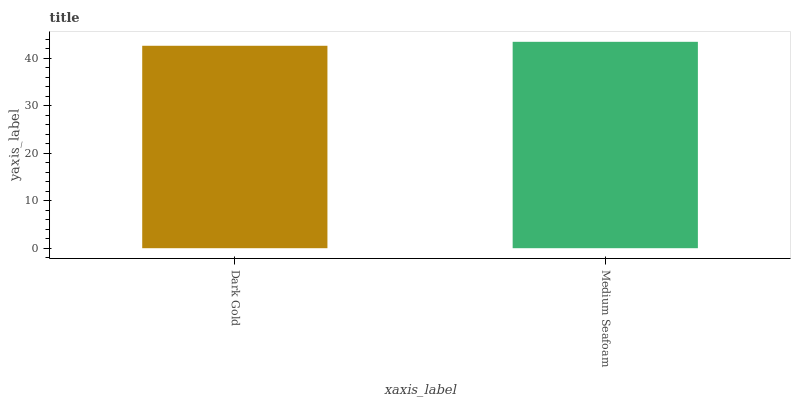Is Dark Gold the minimum?
Answer yes or no. Yes. Is Medium Seafoam the maximum?
Answer yes or no. Yes. Is Medium Seafoam the minimum?
Answer yes or no. No. Is Medium Seafoam greater than Dark Gold?
Answer yes or no. Yes. Is Dark Gold less than Medium Seafoam?
Answer yes or no. Yes. Is Dark Gold greater than Medium Seafoam?
Answer yes or no. No. Is Medium Seafoam less than Dark Gold?
Answer yes or no. No. Is Medium Seafoam the high median?
Answer yes or no. Yes. Is Dark Gold the low median?
Answer yes or no. Yes. Is Dark Gold the high median?
Answer yes or no. No. Is Medium Seafoam the low median?
Answer yes or no. No. 